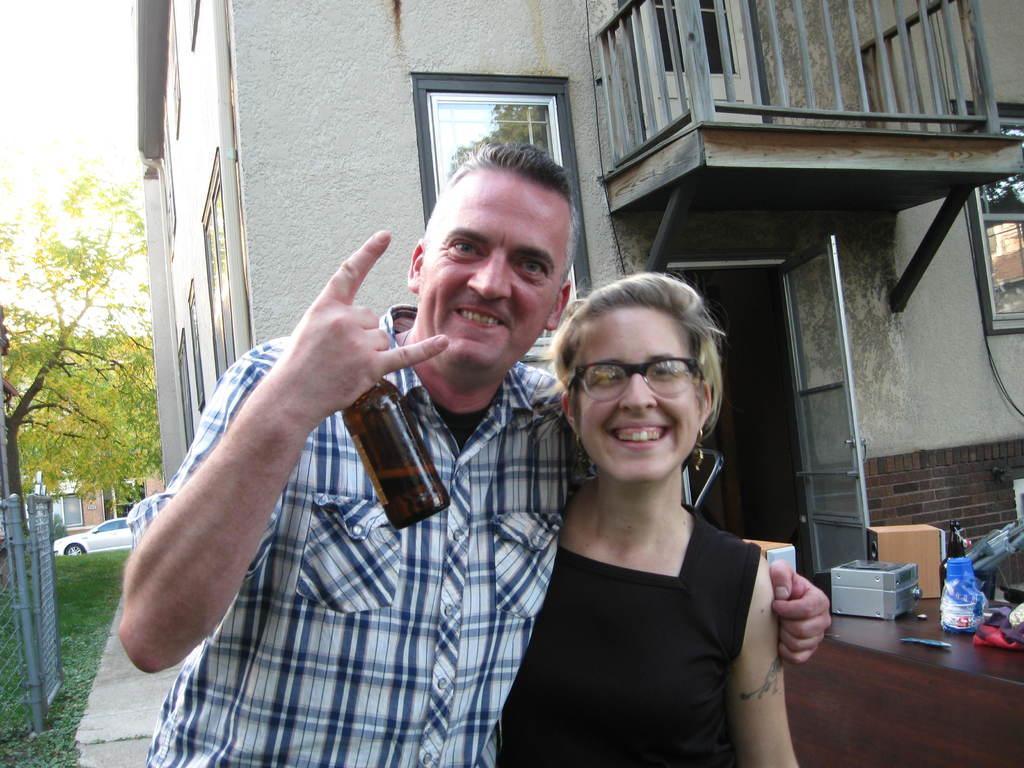How would you summarize this image in a sentence or two? There is a man and woman together and the man is holding bottle in his hand. In the background there is a building,tree,vehicles and fence. 